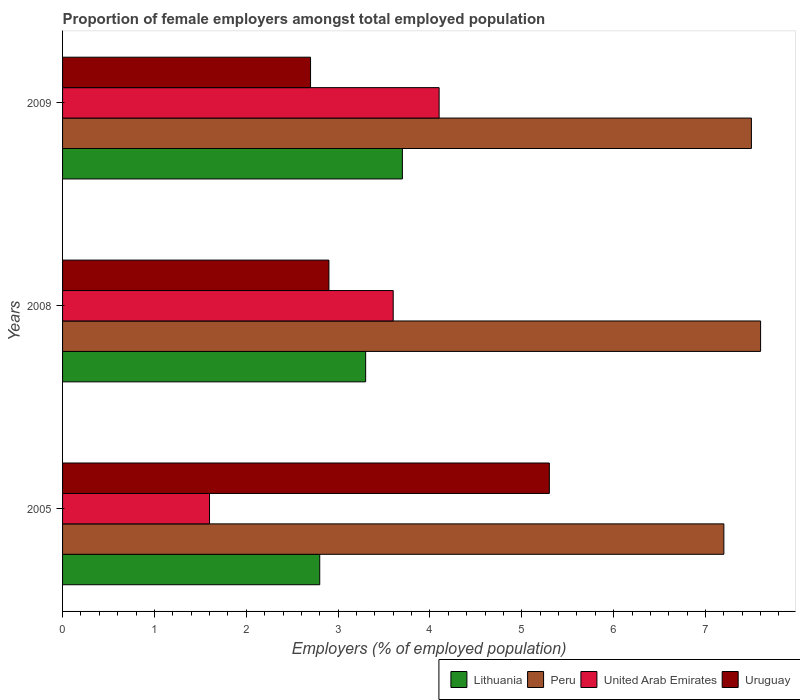How many different coloured bars are there?
Ensure brevity in your answer.  4. How many bars are there on the 1st tick from the top?
Provide a short and direct response. 4. What is the label of the 2nd group of bars from the top?
Provide a short and direct response. 2008. In how many cases, is the number of bars for a given year not equal to the number of legend labels?
Provide a short and direct response. 0. What is the proportion of female employers in Lithuania in 2009?
Offer a terse response. 3.7. Across all years, what is the maximum proportion of female employers in Lithuania?
Give a very brief answer. 3.7. Across all years, what is the minimum proportion of female employers in Uruguay?
Keep it short and to the point. 2.7. In which year was the proportion of female employers in Lithuania maximum?
Give a very brief answer. 2009. In which year was the proportion of female employers in Peru minimum?
Ensure brevity in your answer.  2005. What is the total proportion of female employers in Lithuania in the graph?
Provide a succinct answer. 9.8. What is the difference between the proportion of female employers in Uruguay in 2008 and that in 2009?
Your response must be concise. 0.2. What is the difference between the proportion of female employers in Peru in 2005 and the proportion of female employers in Lithuania in 2009?
Ensure brevity in your answer.  3.5. What is the average proportion of female employers in United Arab Emirates per year?
Make the answer very short. 3.1. In the year 2009, what is the difference between the proportion of female employers in Lithuania and proportion of female employers in Peru?
Your response must be concise. -3.8. What is the ratio of the proportion of female employers in United Arab Emirates in 2005 to that in 2008?
Offer a very short reply. 0.44. What is the difference between the highest and the second highest proportion of female employers in Peru?
Provide a short and direct response. 0.1. What is the difference between the highest and the lowest proportion of female employers in Lithuania?
Keep it short and to the point. 0.9. In how many years, is the proportion of female employers in United Arab Emirates greater than the average proportion of female employers in United Arab Emirates taken over all years?
Offer a very short reply. 2. What does the 2nd bar from the top in 2009 represents?
Your response must be concise. United Arab Emirates. What does the 1st bar from the bottom in 2008 represents?
Your answer should be compact. Lithuania. How many bars are there?
Ensure brevity in your answer.  12. How many years are there in the graph?
Provide a succinct answer. 3. Are the values on the major ticks of X-axis written in scientific E-notation?
Provide a short and direct response. No. How many legend labels are there?
Your response must be concise. 4. How are the legend labels stacked?
Give a very brief answer. Horizontal. What is the title of the graph?
Keep it short and to the point. Proportion of female employers amongst total employed population. What is the label or title of the X-axis?
Offer a terse response. Employers (% of employed population). What is the Employers (% of employed population) in Lithuania in 2005?
Offer a very short reply. 2.8. What is the Employers (% of employed population) in Peru in 2005?
Your answer should be compact. 7.2. What is the Employers (% of employed population) of United Arab Emirates in 2005?
Keep it short and to the point. 1.6. What is the Employers (% of employed population) in Uruguay in 2005?
Keep it short and to the point. 5.3. What is the Employers (% of employed population) in Lithuania in 2008?
Provide a succinct answer. 3.3. What is the Employers (% of employed population) of Peru in 2008?
Your answer should be very brief. 7.6. What is the Employers (% of employed population) of United Arab Emirates in 2008?
Keep it short and to the point. 3.6. What is the Employers (% of employed population) of Uruguay in 2008?
Keep it short and to the point. 2.9. What is the Employers (% of employed population) in Lithuania in 2009?
Your answer should be compact. 3.7. What is the Employers (% of employed population) of United Arab Emirates in 2009?
Offer a terse response. 4.1. What is the Employers (% of employed population) of Uruguay in 2009?
Provide a short and direct response. 2.7. Across all years, what is the maximum Employers (% of employed population) in Lithuania?
Make the answer very short. 3.7. Across all years, what is the maximum Employers (% of employed population) of Peru?
Offer a very short reply. 7.6. Across all years, what is the maximum Employers (% of employed population) in United Arab Emirates?
Provide a short and direct response. 4.1. Across all years, what is the maximum Employers (% of employed population) in Uruguay?
Your answer should be very brief. 5.3. Across all years, what is the minimum Employers (% of employed population) in Lithuania?
Provide a succinct answer. 2.8. Across all years, what is the minimum Employers (% of employed population) of Peru?
Offer a very short reply. 7.2. Across all years, what is the minimum Employers (% of employed population) of United Arab Emirates?
Your response must be concise. 1.6. Across all years, what is the minimum Employers (% of employed population) of Uruguay?
Give a very brief answer. 2.7. What is the total Employers (% of employed population) of Lithuania in the graph?
Offer a terse response. 9.8. What is the total Employers (% of employed population) in Peru in the graph?
Offer a very short reply. 22.3. What is the total Employers (% of employed population) in Uruguay in the graph?
Give a very brief answer. 10.9. What is the difference between the Employers (% of employed population) of Lithuania in 2005 and that in 2008?
Provide a succinct answer. -0.5. What is the difference between the Employers (% of employed population) of Uruguay in 2005 and that in 2008?
Your answer should be compact. 2.4. What is the difference between the Employers (% of employed population) in Lithuania in 2005 and that in 2009?
Provide a short and direct response. -0.9. What is the difference between the Employers (% of employed population) in United Arab Emirates in 2005 and that in 2009?
Offer a very short reply. -2.5. What is the difference between the Employers (% of employed population) in Lithuania in 2008 and that in 2009?
Your response must be concise. -0.4. What is the difference between the Employers (% of employed population) in United Arab Emirates in 2008 and that in 2009?
Give a very brief answer. -0.5. What is the difference between the Employers (% of employed population) in Lithuania in 2005 and the Employers (% of employed population) in United Arab Emirates in 2008?
Offer a terse response. -0.8. What is the difference between the Employers (% of employed population) in United Arab Emirates in 2005 and the Employers (% of employed population) in Uruguay in 2008?
Provide a succinct answer. -1.3. What is the difference between the Employers (% of employed population) of Lithuania in 2005 and the Employers (% of employed population) of Peru in 2009?
Provide a short and direct response. -4.7. What is the difference between the Employers (% of employed population) in Lithuania in 2005 and the Employers (% of employed population) in United Arab Emirates in 2009?
Keep it short and to the point. -1.3. What is the difference between the Employers (% of employed population) in Peru in 2005 and the Employers (% of employed population) in United Arab Emirates in 2009?
Keep it short and to the point. 3.1. What is the difference between the Employers (% of employed population) of Peru in 2005 and the Employers (% of employed population) of Uruguay in 2009?
Provide a succinct answer. 4.5. What is the difference between the Employers (% of employed population) in Lithuania in 2008 and the Employers (% of employed population) in United Arab Emirates in 2009?
Offer a very short reply. -0.8. What is the difference between the Employers (% of employed population) of Lithuania in 2008 and the Employers (% of employed population) of Uruguay in 2009?
Ensure brevity in your answer.  0.6. What is the difference between the Employers (% of employed population) of Peru in 2008 and the Employers (% of employed population) of Uruguay in 2009?
Provide a succinct answer. 4.9. What is the average Employers (% of employed population) in Lithuania per year?
Provide a succinct answer. 3.27. What is the average Employers (% of employed population) of Peru per year?
Keep it short and to the point. 7.43. What is the average Employers (% of employed population) of United Arab Emirates per year?
Your answer should be compact. 3.1. What is the average Employers (% of employed population) in Uruguay per year?
Offer a very short reply. 3.63. In the year 2005, what is the difference between the Employers (% of employed population) in Lithuania and Employers (% of employed population) in Peru?
Provide a short and direct response. -4.4. In the year 2005, what is the difference between the Employers (% of employed population) in Lithuania and Employers (% of employed population) in United Arab Emirates?
Give a very brief answer. 1.2. In the year 2005, what is the difference between the Employers (% of employed population) in Lithuania and Employers (% of employed population) in Uruguay?
Your answer should be very brief. -2.5. In the year 2005, what is the difference between the Employers (% of employed population) of Peru and Employers (% of employed population) of Uruguay?
Your answer should be compact. 1.9. In the year 2005, what is the difference between the Employers (% of employed population) of United Arab Emirates and Employers (% of employed population) of Uruguay?
Your response must be concise. -3.7. In the year 2008, what is the difference between the Employers (% of employed population) of Lithuania and Employers (% of employed population) of Peru?
Your response must be concise. -4.3. In the year 2008, what is the difference between the Employers (% of employed population) in Peru and Employers (% of employed population) in United Arab Emirates?
Your answer should be very brief. 4. In the year 2008, what is the difference between the Employers (% of employed population) in Peru and Employers (% of employed population) in Uruguay?
Make the answer very short. 4.7. In the year 2008, what is the difference between the Employers (% of employed population) in United Arab Emirates and Employers (% of employed population) in Uruguay?
Your answer should be very brief. 0.7. In the year 2009, what is the difference between the Employers (% of employed population) in Lithuania and Employers (% of employed population) in United Arab Emirates?
Offer a terse response. -0.4. In the year 2009, what is the difference between the Employers (% of employed population) of Lithuania and Employers (% of employed population) of Uruguay?
Keep it short and to the point. 1. In the year 2009, what is the difference between the Employers (% of employed population) of Peru and Employers (% of employed population) of Uruguay?
Your response must be concise. 4.8. In the year 2009, what is the difference between the Employers (% of employed population) in United Arab Emirates and Employers (% of employed population) in Uruguay?
Make the answer very short. 1.4. What is the ratio of the Employers (% of employed population) in Lithuania in 2005 to that in 2008?
Your answer should be very brief. 0.85. What is the ratio of the Employers (% of employed population) in Peru in 2005 to that in 2008?
Ensure brevity in your answer.  0.95. What is the ratio of the Employers (% of employed population) of United Arab Emirates in 2005 to that in 2008?
Offer a terse response. 0.44. What is the ratio of the Employers (% of employed population) in Uruguay in 2005 to that in 2008?
Your response must be concise. 1.83. What is the ratio of the Employers (% of employed population) of Lithuania in 2005 to that in 2009?
Give a very brief answer. 0.76. What is the ratio of the Employers (% of employed population) of United Arab Emirates in 2005 to that in 2009?
Provide a short and direct response. 0.39. What is the ratio of the Employers (% of employed population) of Uruguay in 2005 to that in 2009?
Make the answer very short. 1.96. What is the ratio of the Employers (% of employed population) of Lithuania in 2008 to that in 2009?
Provide a short and direct response. 0.89. What is the ratio of the Employers (% of employed population) of Peru in 2008 to that in 2009?
Keep it short and to the point. 1.01. What is the ratio of the Employers (% of employed population) of United Arab Emirates in 2008 to that in 2009?
Ensure brevity in your answer.  0.88. What is the ratio of the Employers (% of employed population) of Uruguay in 2008 to that in 2009?
Provide a short and direct response. 1.07. What is the difference between the highest and the second highest Employers (% of employed population) in Uruguay?
Your response must be concise. 2.4. What is the difference between the highest and the lowest Employers (% of employed population) in Lithuania?
Ensure brevity in your answer.  0.9. What is the difference between the highest and the lowest Employers (% of employed population) of Peru?
Offer a very short reply. 0.4. What is the difference between the highest and the lowest Employers (% of employed population) of Uruguay?
Make the answer very short. 2.6. 